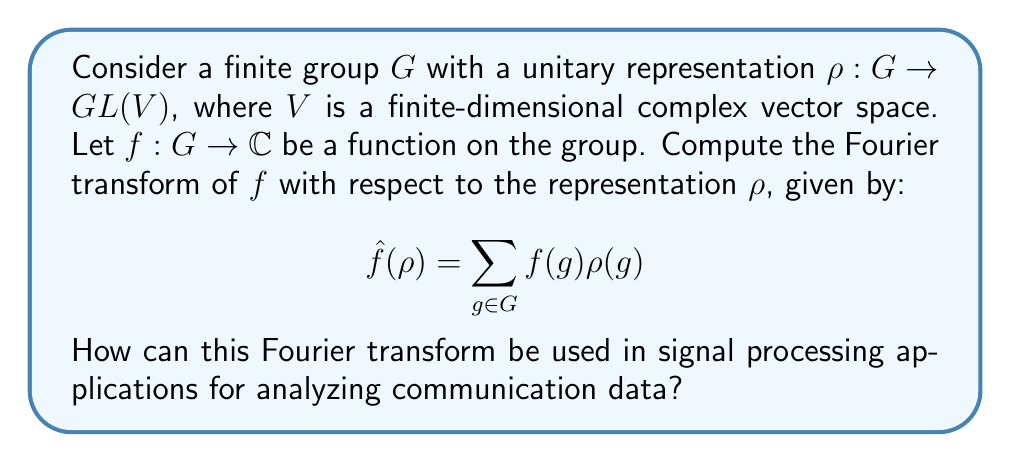Could you help me with this problem? 1. Understanding the Fourier transform in group representation:
   The Fourier transform $\hat{f}(\rho)$ maps a function $f$ on the group $G$ to an operator on the vector space $V$.

2. Computation of the Fourier transform:
   For each $g \in G$, we multiply $f(g)$ by the matrix $\rho(g)$ and sum over all elements of $G$.

3. Properties of the Fourier transform:
   - Linearity: $\widehat{(af + bg)}(\rho) = a\hat{f}(\rho) + b\hat{g}(\rho)$
   - Convolution theorem: $\widehat{(f * g)}(\rho) = \hat{f}(\rho)\hat{g}(\rho)$

4. Application to signal processing:
   a) Group structure in communication data:
      - Time shifts form a cyclic group
      - Frequency shifts form another cyclic group
      - Together, they form the time-frequency plane, which has a Heisenberg group structure

   b) Representation choice:
      - For time domain: regular representation
      - For frequency domain: Fourier basis representation

   c) Analysis of communication signals:
      - Apply the Fourier transform to decompose signals into components
      - Identify patterns and symmetries in the data
      - Filter noise and extract relevant features

   d) Efficient algorithms:
      - Fast Fourier Transform (FFT) for cyclic groups
      - Generalized FFT for other group structures

5. Benefits for communication data mining:
   - Reveal hidden structures in the data
   - Compress information efficiently
   - Develop invariant features for machine learning algorithms
   - Improve signal-to-noise ratio in noisy channels
Answer: $\hat{f}(\rho) = \sum_{g \in G} f(g) \rho(g)$; Used for decomposing signals, identifying patterns, filtering noise, and extracting features in communication data. 